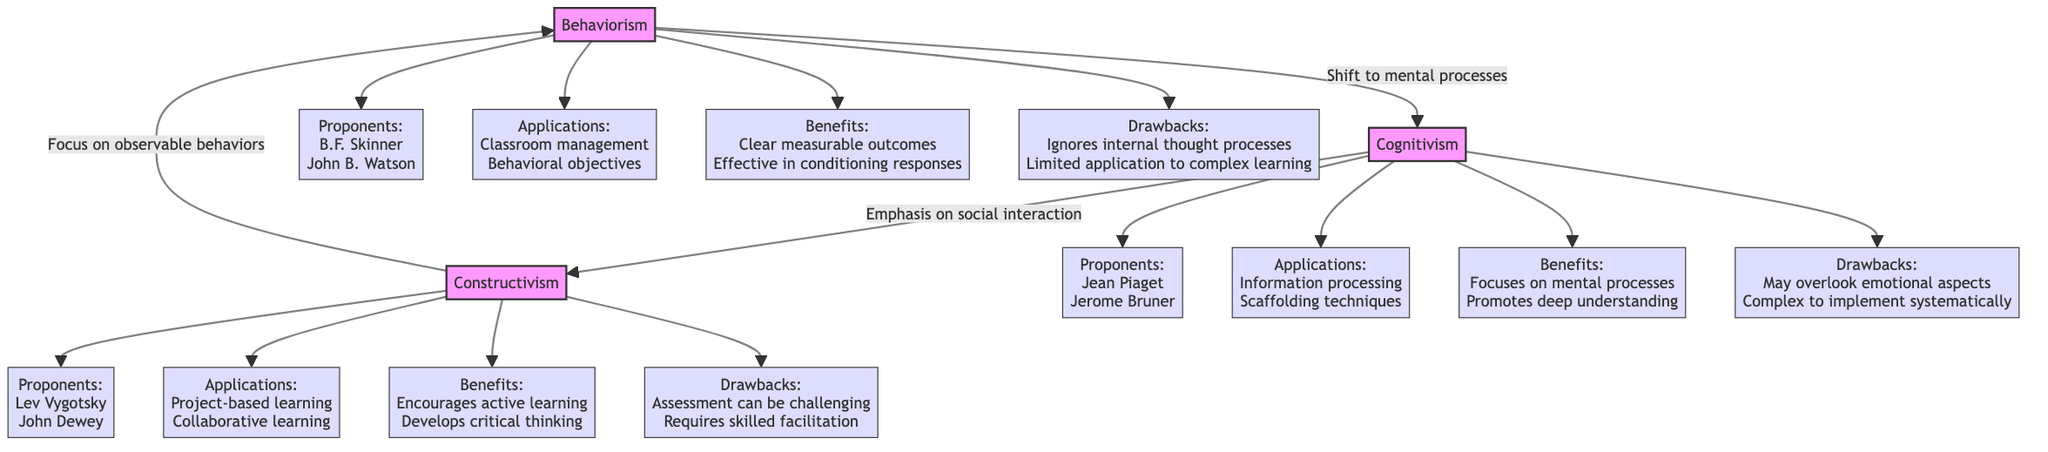What are the proponents of Behaviorism? The diagram lists B.F. Skinner and John B. Watson as the proponents of Behaviorism, which can be found in the node connected to Behaviorism labeled "Proponents."
Answer: B.F. Skinner, John B. Watson What learning application is associated with Cognitivism? The diagram indicates that "Information processing" and "Scaffolding techniques" are the applications associated with Cognitivism, which are shown in the connected node labeled "Applications."
Answer: Information processing, Scaffolding techniques How many drawbacks are listed for Constructivism? The diagram shows one connected node labeled "Drawbacks" under Constructivism with the text detailing the drawbacks. Since it provides one set of drawbacks, the answer is based on how many specific points are included. There are two main points listed in the diagram about drawbacks.
Answer: 2 What relationship does Cognitivism have with Constructivism? The diagram shows an arrow from Cognitivism to Constructivism labeled "Emphasis on social interaction," indicating a connection. The nature of this label shows how Cognitivism relates to Constructivism regarding social considerations in learning.
Answer: Emphasis on social interaction What benefit is listed for Behaviorism? The node connected to Behaviorism under the label "Benefits" mentions "Clear measurable outcomes" and "Effective in conditioning responses." There are multiple benefits listed, and the answer is based on one of the prominent points.
Answer: Clear measurable outcomes What does Constructivism encourage in learners? The diagram notes that Constructivism "Encourages active learning" and "Develops critical thinking" as benefits, which inform what it encourages in learners. Focusing on the first benefit gives insight into its primary aim.
Answer: Active learning Which theory has Jean Piaget as a proponent? The diagram indicates that Jean Piaget is associated with Cognitivism, which is confirmed by tracing the line from Cognitivism to the "Proponents" node that lists him.
Answer: Cognitivism What is a complexity associated with Cognitivism? The drawbacks of Cognitivism include "Complex to implement systematically," which is specified within the drawbacks connected to the Cognitivism node. This identifies a significant challenge when applying this theory in educational settings.
Answer: Complex to implement systematically What aspect of learning does Behaviorism focus on? The diagram suggests that Behaviorism focuses on "observable behaviors," indicated in the connected node labeled "Drawbacks" under Behaviorism. This highlights the primary characteristic of what Behaviorism addresses in learning.
Answer: Observable behaviors 